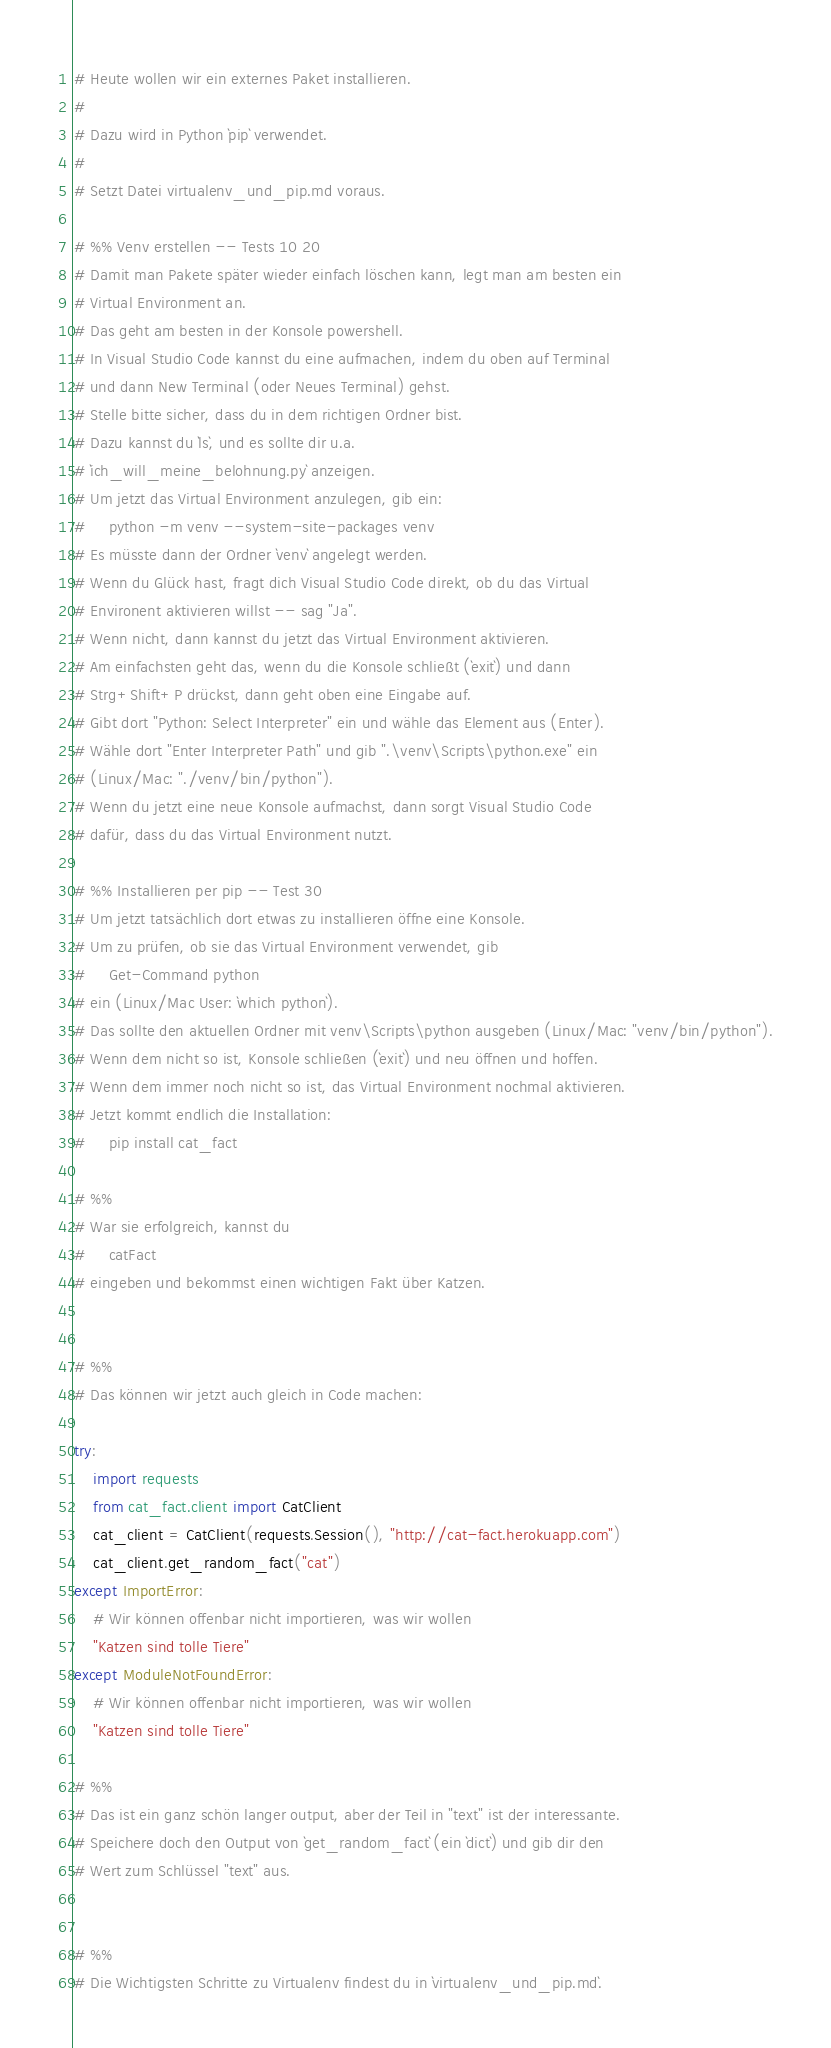<code> <loc_0><loc_0><loc_500><loc_500><_Python_># Heute wollen wir ein externes Paket installieren.
#
# Dazu wird in Python `pip` verwendet.
#
# Setzt Datei virtualenv_und_pip.md voraus.

# %% Venv erstellen -- Tests 10 20
# Damit man Pakete später wieder einfach löschen kann, legt man am besten ein
# Virtual Environment an.
# Das geht am besten in der Konsole powershell.
# In Visual Studio Code kannst du eine aufmachen, indem du oben auf Terminal
# und dann New Terminal (oder Neues Terminal) gehst.
# Stelle bitte sicher, dass du in dem richtigen Ordner bist.
# Dazu kannst du `ls`, und es sollte dir u.a.
# `ich_will_meine_belohnung.py` anzeigen.
# Um jetzt das Virtual Environment anzulegen, gib ein:
#     python -m venv --system-site-packages venv
# Es müsste dann der Ordner `venv` angelegt werden.
# Wenn du Glück hast, fragt dich Visual Studio Code direkt, ob du das Virtual
# Environent aktivieren willst -- sag "Ja".
# Wenn nicht, dann kannst du jetzt das Virtual Environment aktivieren.
# Am einfachsten geht das, wenn du die Konsole schließt (`exit`) und dann
# Strg+Shift+P drückst, dann geht oben eine Eingabe auf.
# Gibt dort "Python: Select Interpreter" ein und wähle das Element aus (Enter).
# Wähle dort "Enter Interpreter Path" und gib ".\venv\Scripts\python.exe" ein
# (Linux/Mac: "./venv/bin/python").
# Wenn du jetzt eine neue Konsole aufmachst, dann sorgt Visual Studio Code
# dafür, dass du das Virtual Environment nutzt.

# %% Installieren per pip -- Test 30
# Um jetzt tatsächlich dort etwas zu installieren öffne eine Konsole.
# Um zu prüfen, ob sie das Virtual Environment verwendet, gib
#     Get-Command python
# ein (Linux/Mac User: `which python`).
# Das sollte den aktuellen Ordner mit venv\Scripts\python ausgeben (Linux/Mac: "venv/bin/python").
# Wenn dem nicht so ist, Konsole schließen (`exit`) und neu öffnen und hoffen.
# Wenn dem immer noch nicht so ist, das Virtual Environment nochmal aktivieren.
# Jetzt kommt endlich die Installation:
#     pip install cat_fact

# %%
# War sie erfolgreich, kannst du
#     catFact
# eingeben und bekommst einen wichtigen Fakt über Katzen.


# %%
# Das können wir jetzt auch gleich in Code machen:

try:
    import requests
    from cat_fact.client import CatClient
    cat_client = CatClient(requests.Session(), "http://cat-fact.herokuapp.com")
    cat_client.get_random_fact("cat")
except ImportError:
    # Wir können offenbar nicht importieren, was wir wollen
    "Katzen sind tolle Tiere"
except ModuleNotFoundError:
    # Wir können offenbar nicht importieren, was wir wollen
    "Katzen sind tolle Tiere"

# %%
# Das ist ein ganz schön langer output, aber der Teil in "text" ist der interessante.
# Speichere doch den Output von `get_random_fact` (ein `dict`) und gib dir den
# Wert zum Schlüssel "text" aus.


# %%
# Die Wichtigsten Schritte zu Virtualenv findest du in `virtualenv_und_pip.md`.</code> 